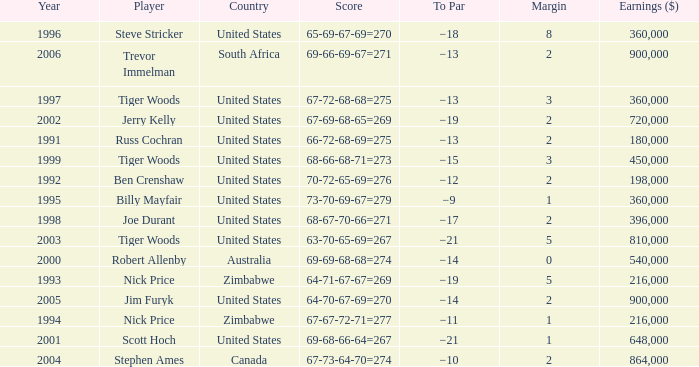How many years have a Player of joe durant, and Earnings ($) larger than 396,000? 0.0. 